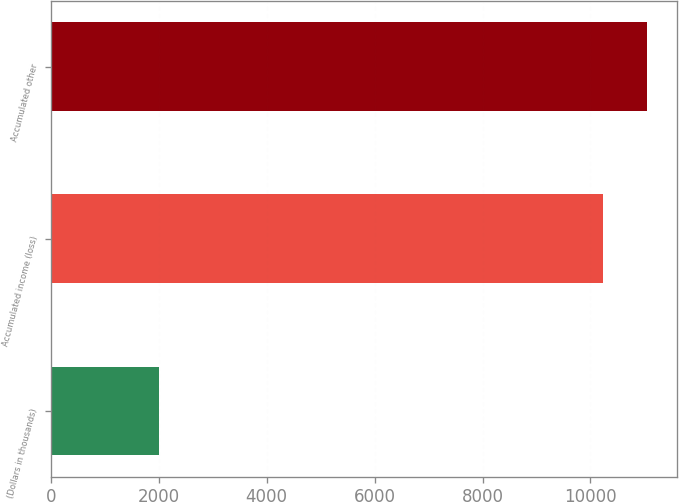<chart> <loc_0><loc_0><loc_500><loc_500><bar_chart><fcel>(Dollars in thousands)<fcel>Accumulated income (loss)<fcel>Accumulated other<nl><fcel>2012<fcel>10231<fcel>11052.9<nl></chart> 